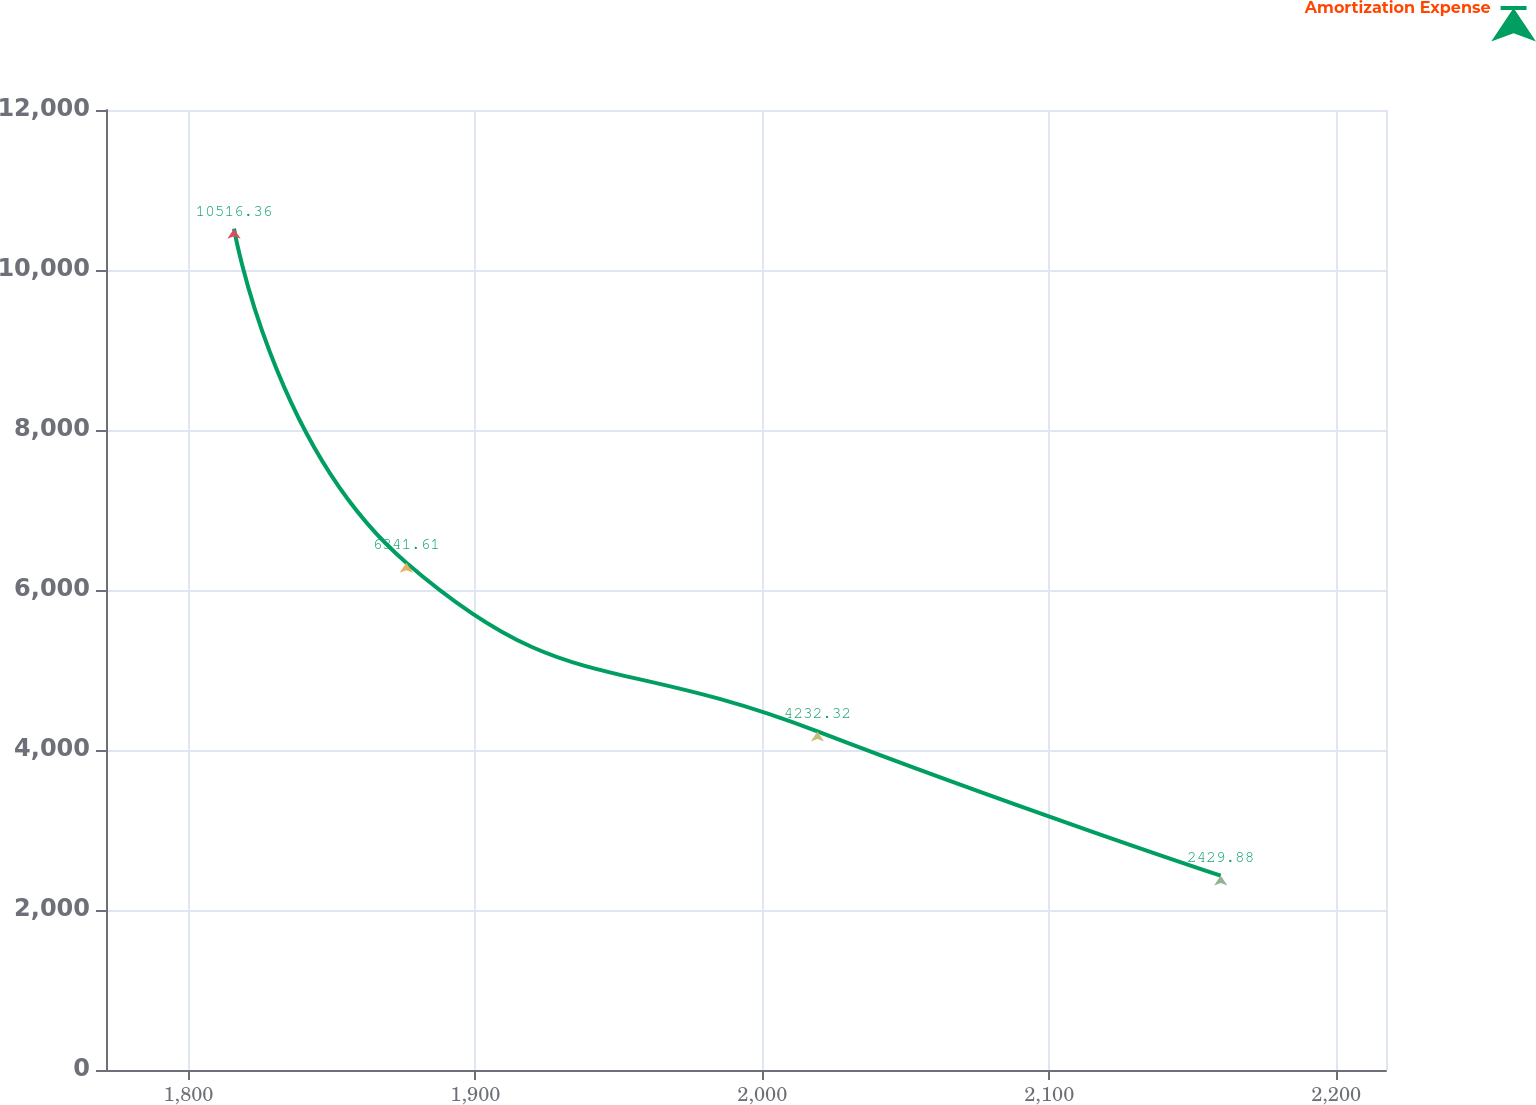Convert chart to OTSL. <chart><loc_0><loc_0><loc_500><loc_500><line_chart><ecel><fcel>Amortization Expense<nl><fcel>1815.87<fcel>10516.4<nl><fcel>1875.92<fcel>6341.61<nl><fcel>2019.22<fcel>4232.32<nl><fcel>2159.76<fcel>2429.88<nl><fcel>2261.98<fcel>195.47<nl></chart> 